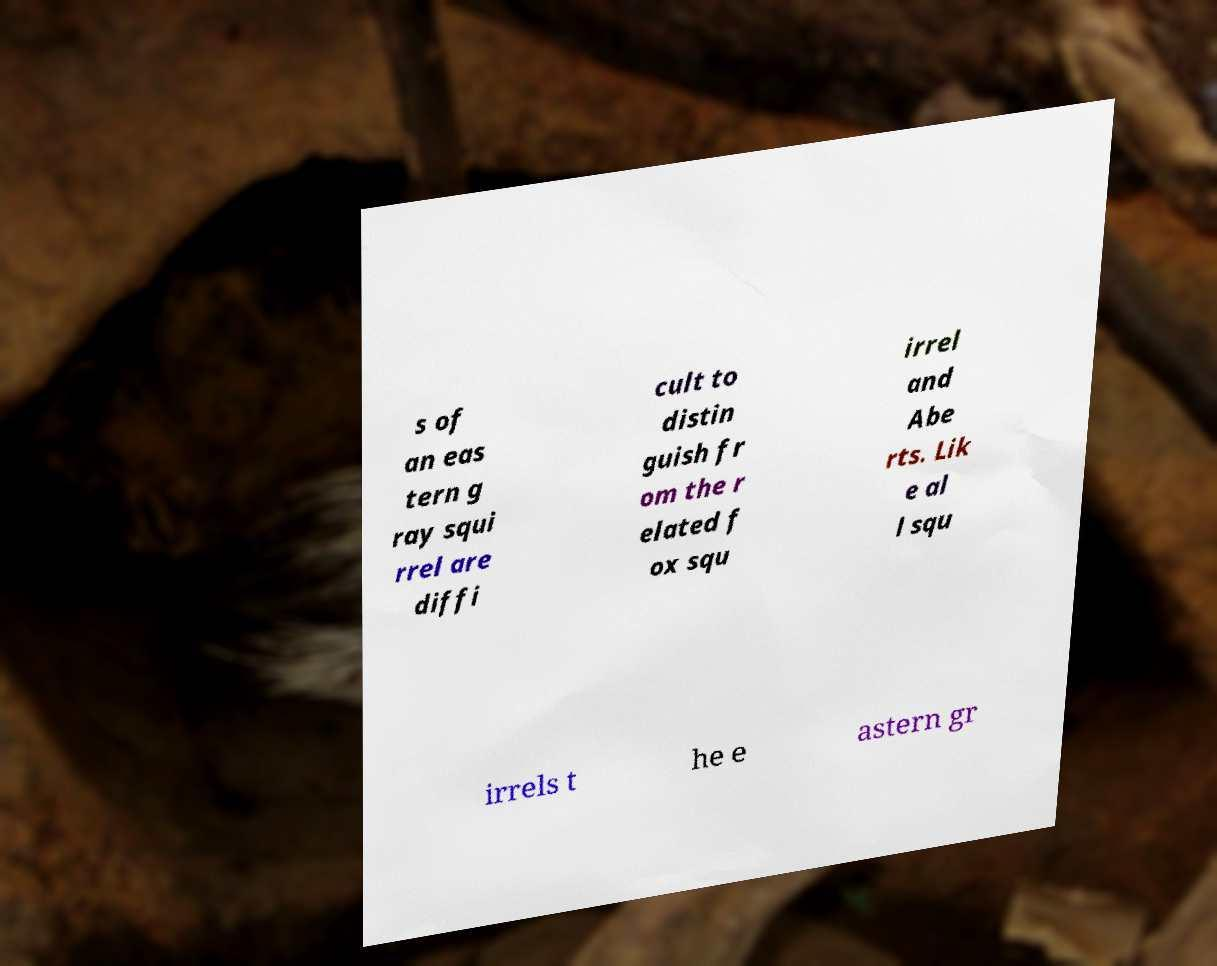There's text embedded in this image that I need extracted. Can you transcribe it verbatim? s of an eas tern g ray squi rrel are diffi cult to distin guish fr om the r elated f ox squ irrel and Abe rts. Lik e al l squ irrels t he e astern gr 